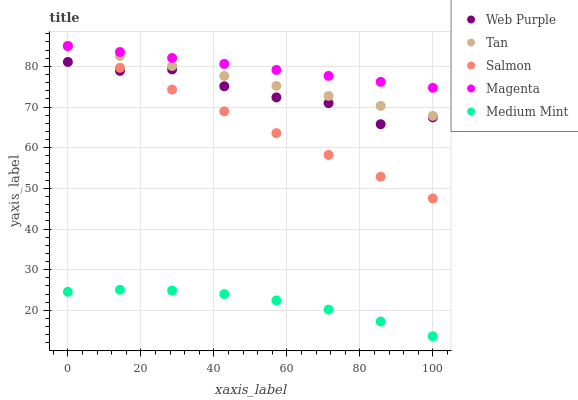Does Medium Mint have the minimum area under the curve?
Answer yes or no. Yes. Does Magenta have the maximum area under the curve?
Answer yes or no. Yes. Does Web Purple have the minimum area under the curve?
Answer yes or no. No. Does Web Purple have the maximum area under the curve?
Answer yes or no. No. Is Salmon the smoothest?
Answer yes or no. Yes. Is Web Purple the roughest?
Answer yes or no. Yes. Is Web Purple the smoothest?
Answer yes or no. No. Is Salmon the roughest?
Answer yes or no. No. Does Medium Mint have the lowest value?
Answer yes or no. Yes. Does Web Purple have the lowest value?
Answer yes or no. No. Does Magenta have the highest value?
Answer yes or no. Yes. Does Web Purple have the highest value?
Answer yes or no. No. Is Medium Mint less than Salmon?
Answer yes or no. Yes. Is Tan greater than Medium Mint?
Answer yes or no. Yes. Does Tan intersect Salmon?
Answer yes or no. Yes. Is Tan less than Salmon?
Answer yes or no. No. Is Tan greater than Salmon?
Answer yes or no. No. Does Medium Mint intersect Salmon?
Answer yes or no. No. 